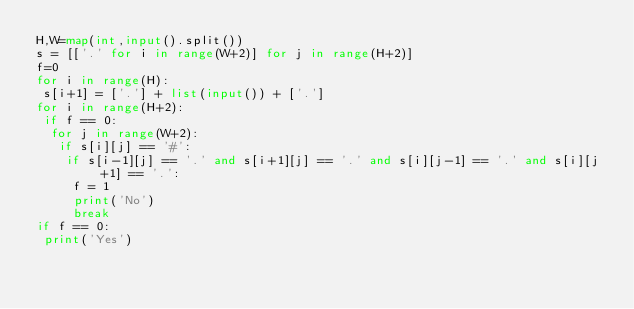Convert code to text. <code><loc_0><loc_0><loc_500><loc_500><_Python_>H,W=map(int,input().split())
s = [['.' for i in range(W+2)] for j in range(H+2)]
f=0
for i in range(H):
 s[i+1] = ['.'] + list(input()) + ['.']
for i in range(H+2):
 if f == 0:
  for j in range(W+2):
   if s[i][j] == '#':
    if s[i-1][j] == '.' and s[i+1][j] == '.' and s[i][j-1] == '.' and s[i][j+1] == '.':
     f = 1
     print('No')
     break
if f == 0:
 print('Yes')</code> 